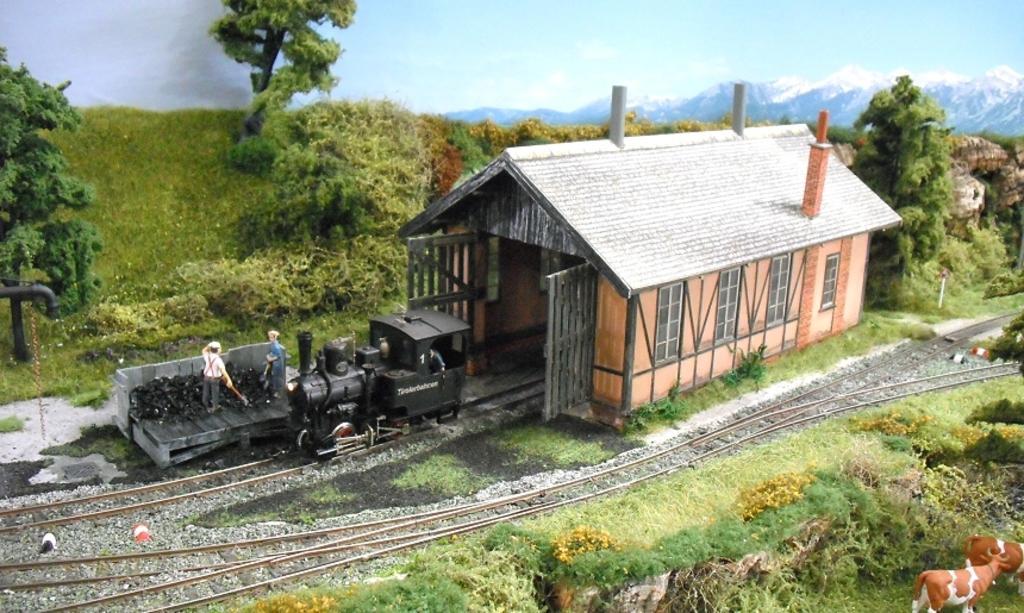How would you summarize this image in a sentence or two? In the foreground of this image, there are plants and the grass and the railway track. In the middle, there is a shelter and a train engine on the track. There are two persons standing on the wooden surface. In the background, there are trees, grass, sky and the mountains. 